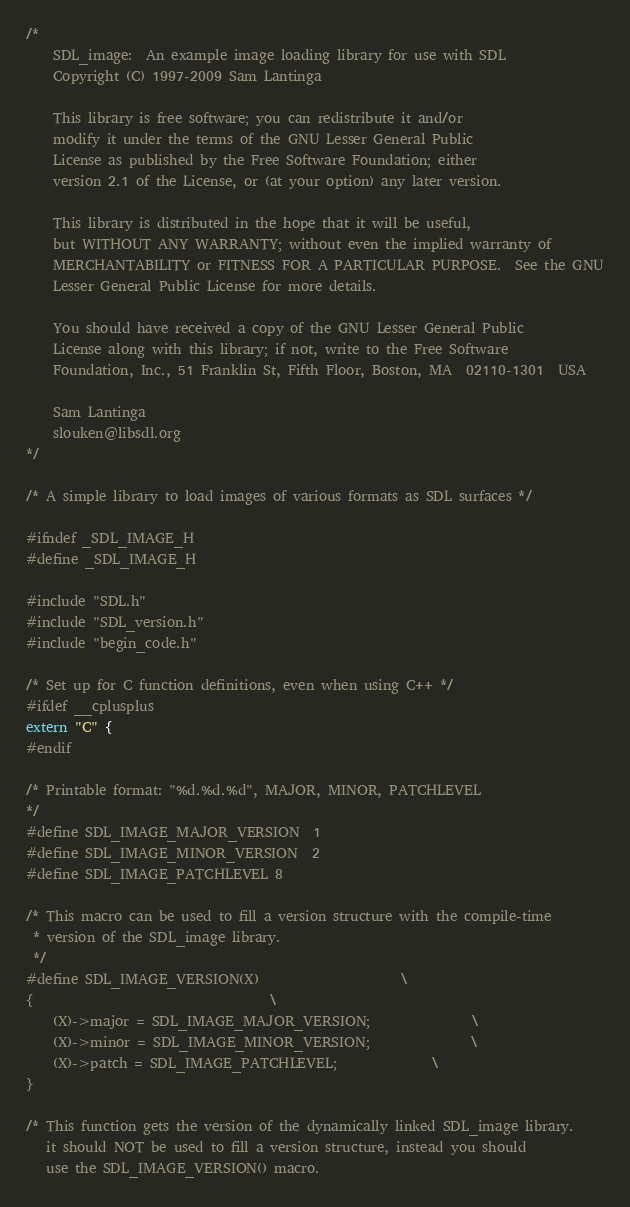<code> <loc_0><loc_0><loc_500><loc_500><_C_>/*
    SDL_image:  An example image loading library for use with SDL
    Copyright (C) 1997-2009 Sam Lantinga

    This library is free software; you can redistribute it and/or
    modify it under the terms of the GNU Lesser General Public
    License as published by the Free Software Foundation; either
    version 2.1 of the License, or (at your option) any later version.

    This library is distributed in the hope that it will be useful,
    but WITHOUT ANY WARRANTY; without even the implied warranty of
    MERCHANTABILITY or FITNESS FOR A PARTICULAR PURPOSE.  See the GNU
    Lesser General Public License for more details.

    You should have received a copy of the GNU Lesser General Public
    License along with this library; if not, write to the Free Software
    Foundation, Inc., 51 Franklin St, Fifth Floor, Boston, MA  02110-1301  USA

    Sam Lantinga
    slouken@libsdl.org
*/

/* A simple library to load images of various formats as SDL surfaces */

#ifndef _SDL_IMAGE_H
#define _SDL_IMAGE_H

#include "SDL.h"
#include "SDL_version.h"
#include "begin_code.h"

/* Set up for C function definitions, even when using C++ */
#ifdef __cplusplus
extern "C" {
#endif

/* Printable format: "%d.%d.%d", MAJOR, MINOR, PATCHLEVEL
*/
#define SDL_IMAGE_MAJOR_VERSION	1
#define SDL_IMAGE_MINOR_VERSION	2
#define SDL_IMAGE_PATCHLEVEL	8

/* This macro can be used to fill a version structure with the compile-time
 * version of the SDL_image library.
 */
#define SDL_IMAGE_VERSION(X)						\
{									\
	(X)->major = SDL_IMAGE_MAJOR_VERSION;				\
	(X)->minor = SDL_IMAGE_MINOR_VERSION;				\
	(X)->patch = SDL_IMAGE_PATCHLEVEL;				\
}

/* This function gets the version of the dynamically linked SDL_image library.
   it should NOT be used to fill a version structure, instead you should
   use the SDL_IMAGE_VERSION() macro.</code> 